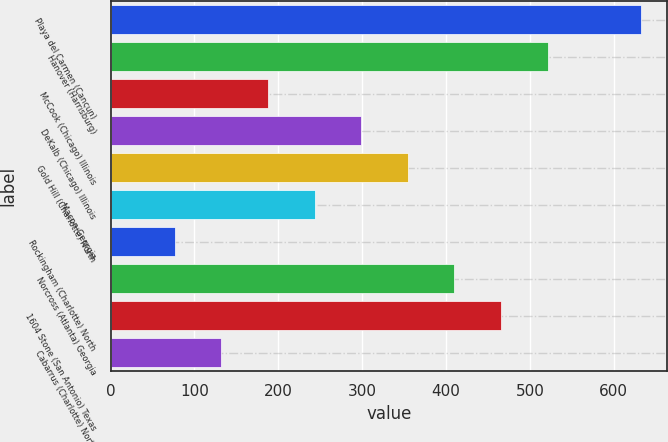Convert chart. <chart><loc_0><loc_0><loc_500><loc_500><bar_chart><fcel>Playa del Carmen (Cancun)<fcel>Hanover (Harrisburg)<fcel>McCook (Chicago) Illinois<fcel>DeKalb (Chicago) Illinois<fcel>Gold Hill (Charlotte) North<fcel>Macon Georgia<fcel>Rockingham (Charlotte) North<fcel>Norcross (Atlanta) Georgia<fcel>1604 Stone (San Antonio) Texas<fcel>Cabarrus (Charlotte) North<nl><fcel>632.4<fcel>521.24<fcel>187.76<fcel>298.92<fcel>354.5<fcel>243.34<fcel>76.6<fcel>410.08<fcel>465.66<fcel>132.18<nl></chart> 